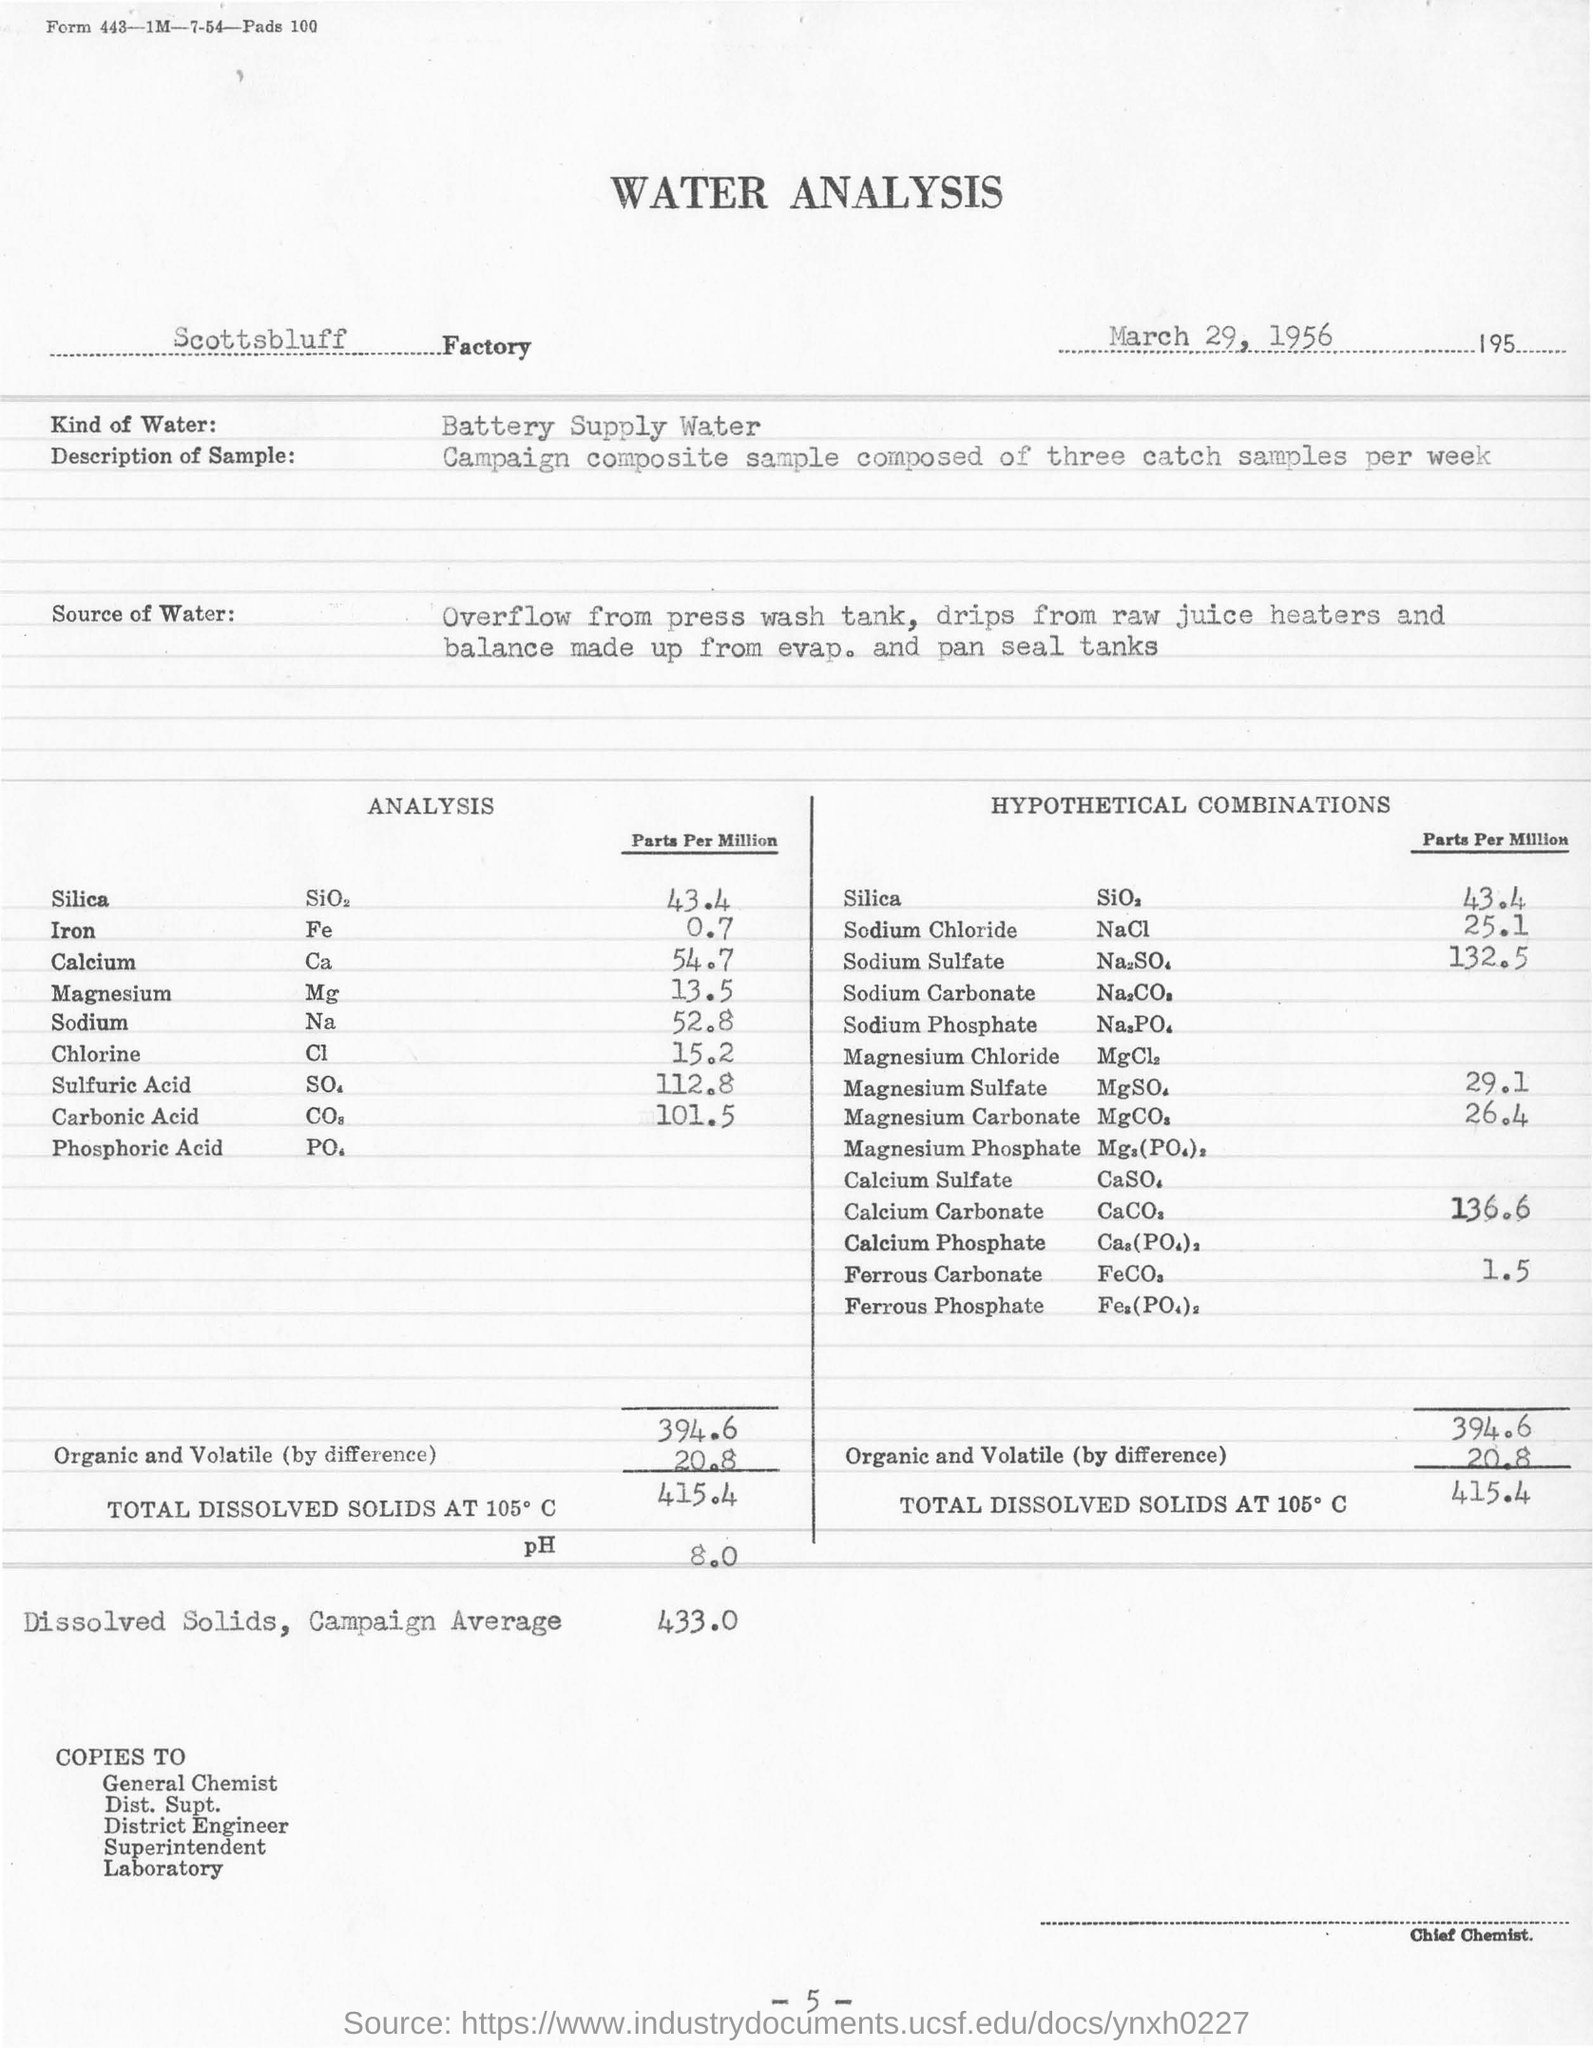Mention a couple of crucial points in this snapshot. The water analysis is conducted at the Scottsbluff factory. The chemicals used in the table are expressed in parts per million. Water samples are collected on a weekly basis, with a minimum of three samples collected per week. 